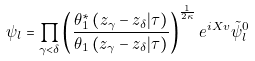<formula> <loc_0><loc_0><loc_500><loc_500>\psi _ { l } = \prod _ { \gamma < \delta } \left ( \frac { \theta _ { 1 } ^ { \ast } \left ( z _ { \gamma } - z _ { \delta } | \tau \right ) } { \theta _ { 1 } \left ( z _ { \gamma } - z _ { \delta } | \tau \right ) } \right ) ^ { \frac { 1 } { 2 \kappa } } e ^ { i X v } { \tilde { \psi } } _ { l } ^ { 0 }</formula> 